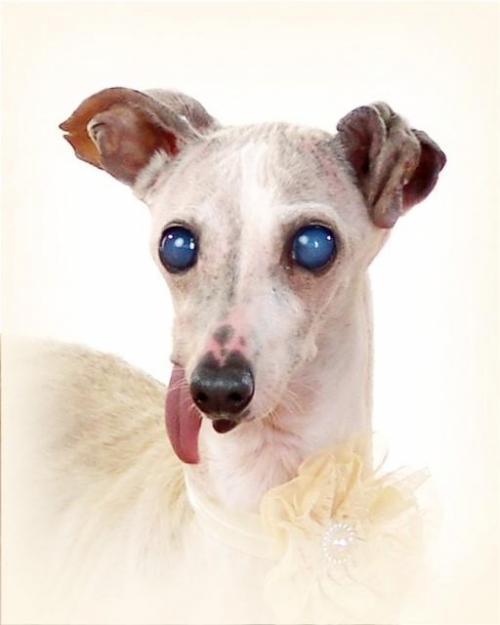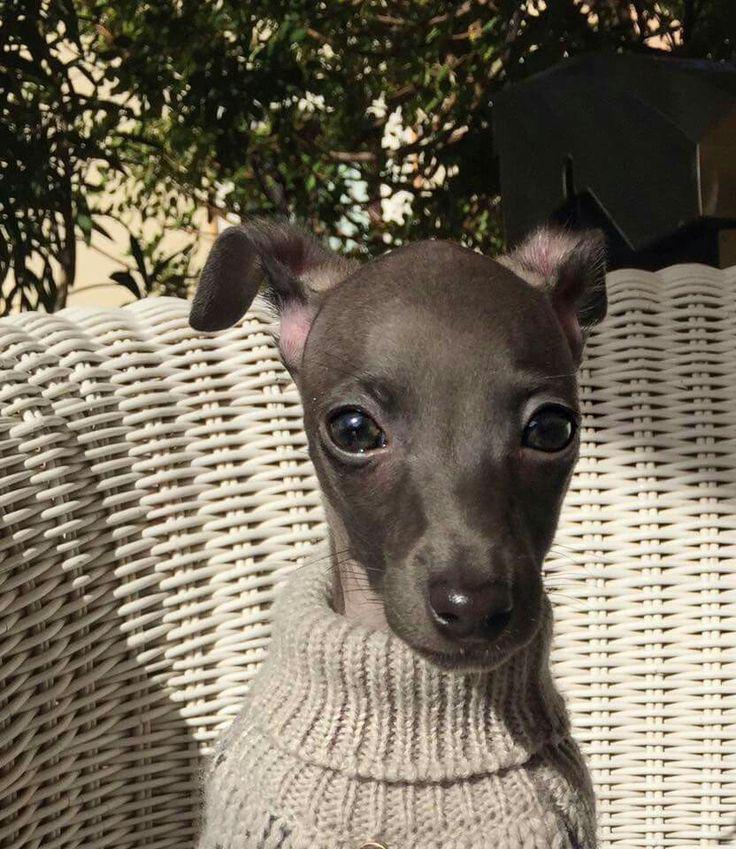The first image is the image on the left, the second image is the image on the right. Assess this claim about the two images: "The dog in one of the images is on a cemented area outside.". Correct or not? Answer yes or no. No. The first image is the image on the left, the second image is the image on the right. Evaluate the accuracy of this statement regarding the images: "An image shows a dog wearing a garment with a turtleneck.". Is it true? Answer yes or no. Yes. 